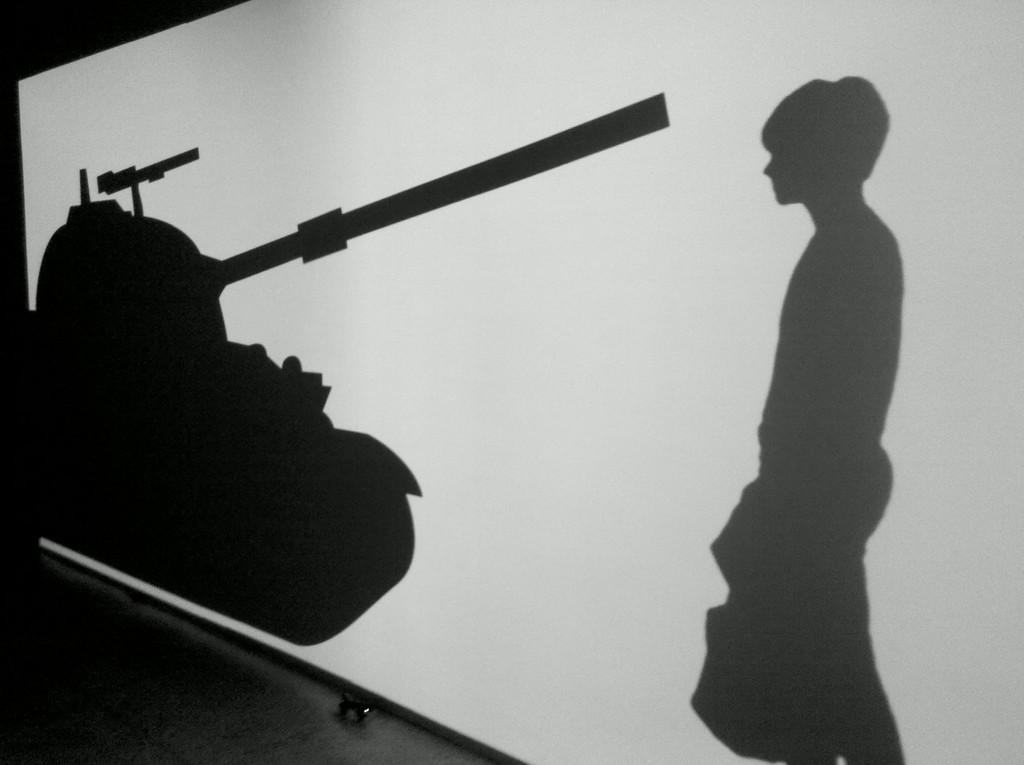Describe this image in one or two sentences. In this picture I can see an image of a person standing and a battle tank on the screen. 